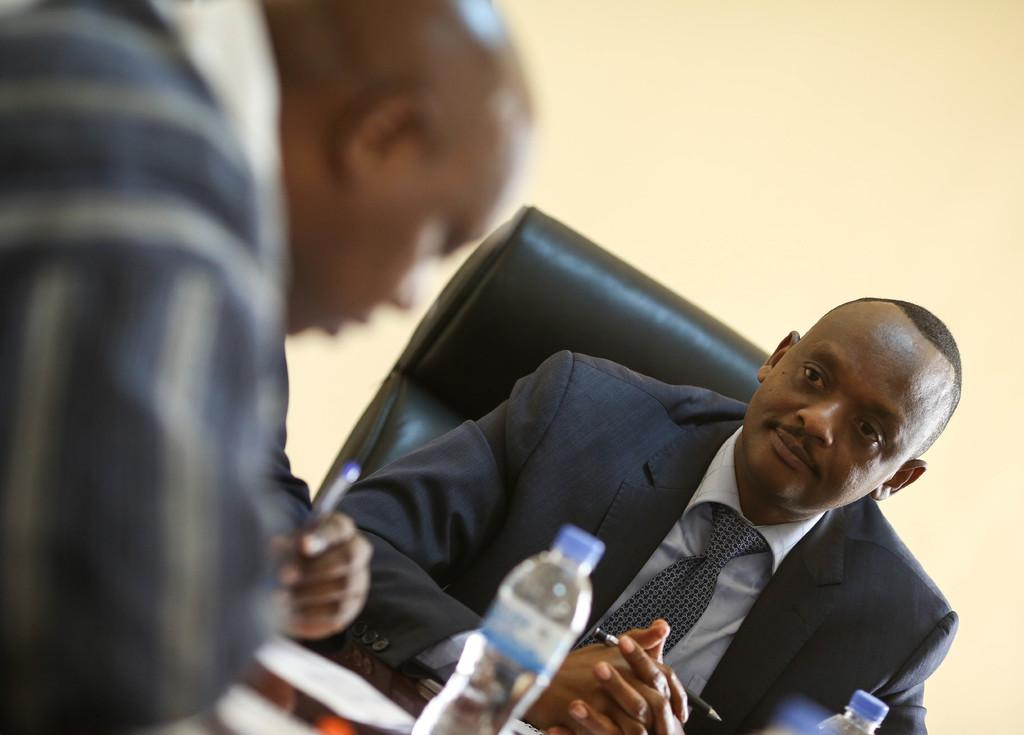How many people are in the image? There are two people in the image. What are the people holding in their hands? The people are holding pens. What can be seen in front of the people? There are bottles and some objects in front of the people. What is visible in the background of the image? There is a chair and a wall in the background of the image. What type of pickle is being used by the people in the image? There is no pickle present in the image; the people are holding pens and there are bottles and other objects in front of them. 